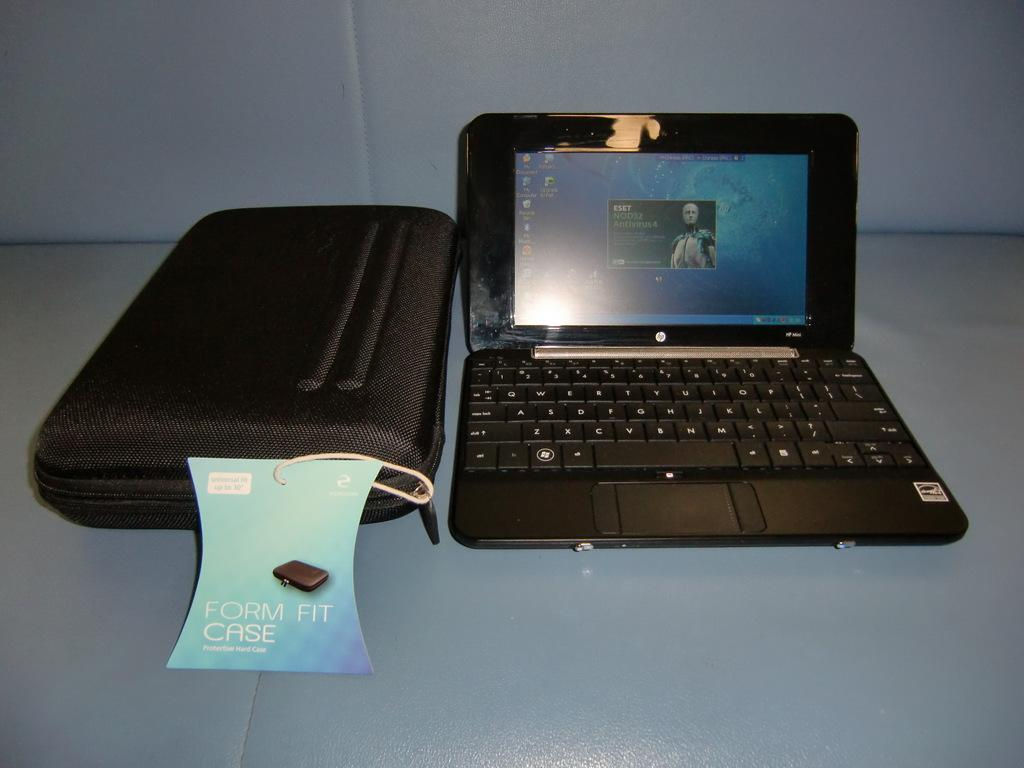<image>
Share a concise interpretation of the image provided. An HP laptop is sitting next to a form fit case. 